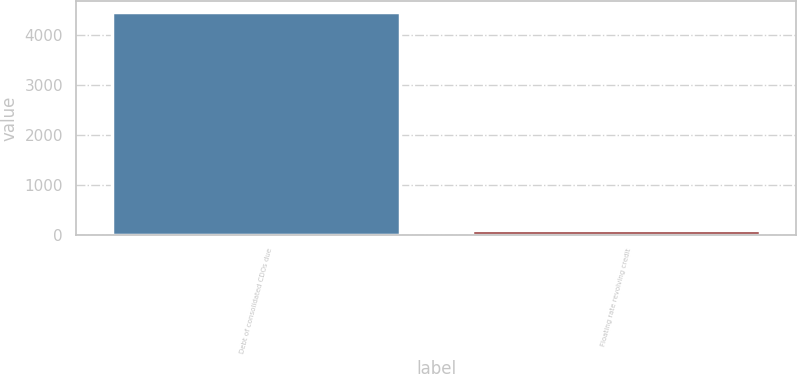Convert chart. <chart><loc_0><loc_0><loc_500><loc_500><bar_chart><fcel>Debt of consolidated CDOs due<fcel>Floating rate revolving credit<nl><fcel>4450<fcel>104<nl></chart> 